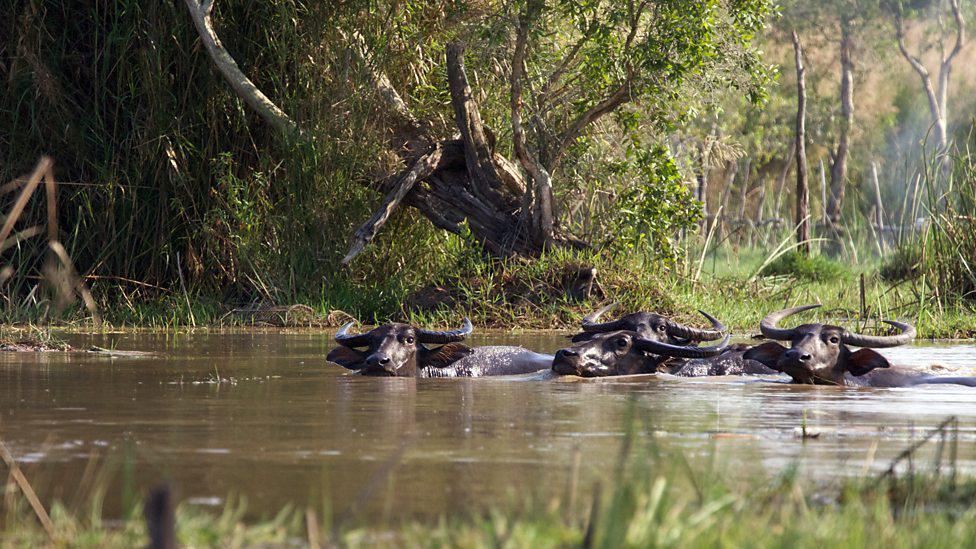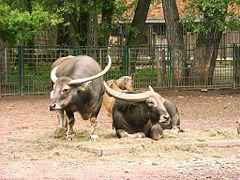The first image is the image on the left, the second image is the image on the right. Examine the images to the left and right. Is the description "The left image contains exactly two water buffaloes." accurate? Answer yes or no. No. The first image is the image on the left, the second image is the image on the right. For the images shown, is this caption "One image shows at least two water buffalo in water up to their chins." true? Answer yes or no. Yes. 